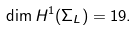Convert formula to latex. <formula><loc_0><loc_0><loc_500><loc_500>\dim H ^ { 1 } ( \Sigma _ { L } ) = 1 9 .</formula> 